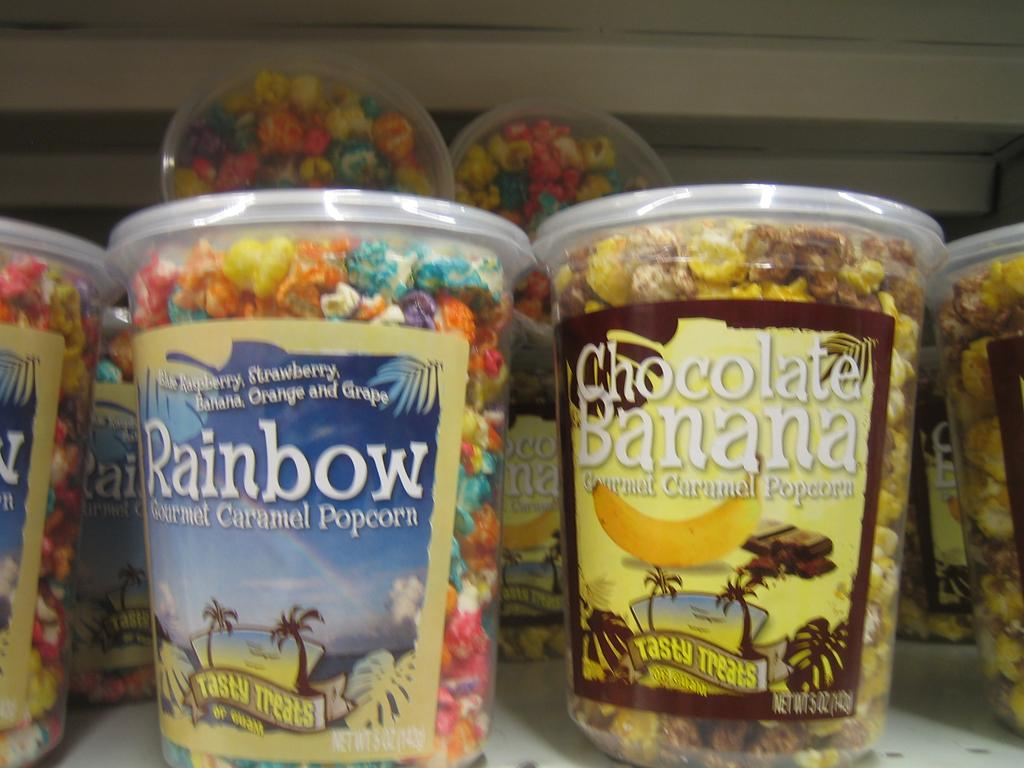What is the main subject of the image? The main subject of the image is many boxes of popcorn. Where are the boxes of popcorn located? The boxes are on a shelf. What information can be found on the boxes? The boxes have labels with text and images. What type of cable is used to connect the boxes of popcorn in the image? There is no cable connecting the boxes of popcorn in the image. 